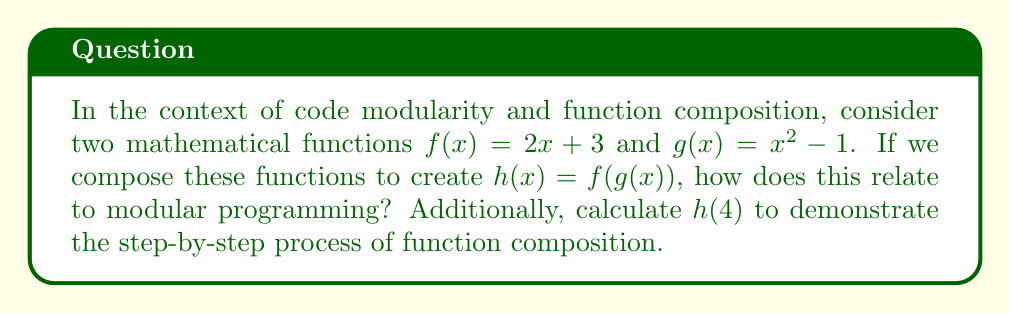Help me with this question. This question relates to code modularity and function composition in the following ways:

1. Function Composition:
   The composition of functions $f(x)$ and $g(x)$ to create $h(x) = f(g(x))$ is analogous to calling one function inside another in programming. This is a fundamental concept in modular programming.

2. Modularity:
   Each function ($f$ and $g$) performs a specific task independently, which aligns with the principle of modularity in programming where each function or module has a distinct responsibility.

3. Reusability:
   The individual functions $f(x)$ and $g(x)$ can be used separately or combined, demonstrating how modular code can be reused in different contexts.

4. Abstraction:
   The composed function $h(x)$ abstracts away the details of $f(x)$ and $g(x)$, similar to how higher-level functions in programming can abstract lower-level operations.

To calculate $h(4)$:

1. First, we evaluate $g(4)$:
   $g(4) = 4^2 - 1 = 16 - 1 = 15$

2. Then, we use this result as input for $f(x)$:
   $f(15) = 2(15) + 3 = 30 + 3 = 33$

Therefore, $h(4) = f(g(4)) = 33$

This step-by-step process demonstrates how function composition works, which is analogous to how nested function calls are evaluated in programming.
Answer: $h(4) = 33$. The composition of functions relates to modular programming by demonstrating function reusability, abstraction, and the ability to break complex operations into simpler, independent tasks. 